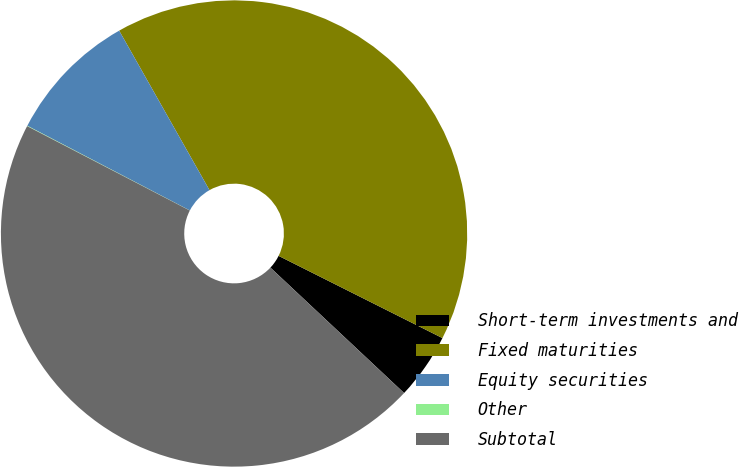<chart> <loc_0><loc_0><loc_500><loc_500><pie_chart><fcel>Short-term investments and<fcel>Fixed maturities<fcel>Equity securities<fcel>Other<fcel>Subtotal<nl><fcel>4.59%<fcel>40.6%<fcel>9.15%<fcel>0.03%<fcel>45.62%<nl></chart> 